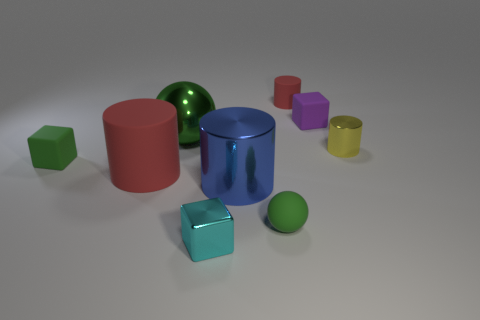There is a green matte thing that is to the right of the large green shiny ball; are there any cylinders behind it?
Provide a short and direct response. Yes. What is the color of the other small rubber object that is the same shape as the purple rubber object?
Your response must be concise. Green. What is the color of the small cylinder that is made of the same material as the tiny purple cube?
Your response must be concise. Red. Is there a big blue object that is right of the ball on the left side of the metallic cylinder in front of the yellow cylinder?
Provide a succinct answer. Yes. Are there fewer green things that are to the right of the small cyan object than rubber things behind the green rubber ball?
Provide a succinct answer. Yes. What number of yellow blocks are the same material as the big blue cylinder?
Provide a short and direct response. 0. There is a green metal object; is it the same size as the red cylinder that is in front of the big green metallic ball?
Provide a succinct answer. Yes. What is the material of the large ball that is the same color as the small sphere?
Keep it short and to the point. Metal. There is a block behind the large shiny object that is behind the small shiny thing that is on the right side of the cyan object; what is its size?
Your answer should be very brief. Small. Are there more blue shiny things left of the purple cube than yellow metal objects that are in front of the small green rubber cube?
Make the answer very short. Yes. 